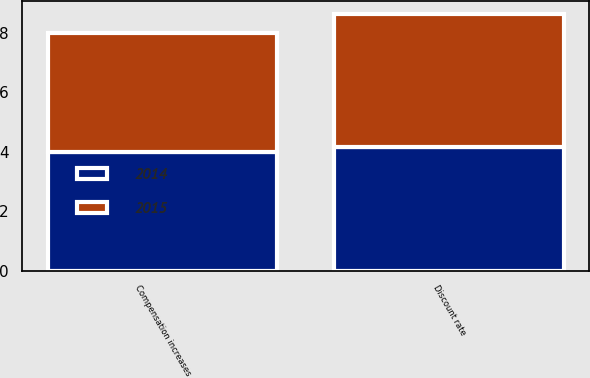Convert chart to OTSL. <chart><loc_0><loc_0><loc_500><loc_500><stacked_bar_chart><ecel><fcel>Discount rate<fcel>Compensation increases<nl><fcel>2015<fcel>4.5<fcel>4<nl><fcel>2014<fcel>4.15<fcel>4<nl></chart> 